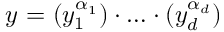Convert formula to latex. <formula><loc_0><loc_0><loc_500><loc_500>y ^ { \ a a } = ( y _ { 1 } ^ { \alpha _ { 1 } } ) \cdot \dots \cdot ( y _ { d } ^ { \alpha _ { d } } )</formula> 